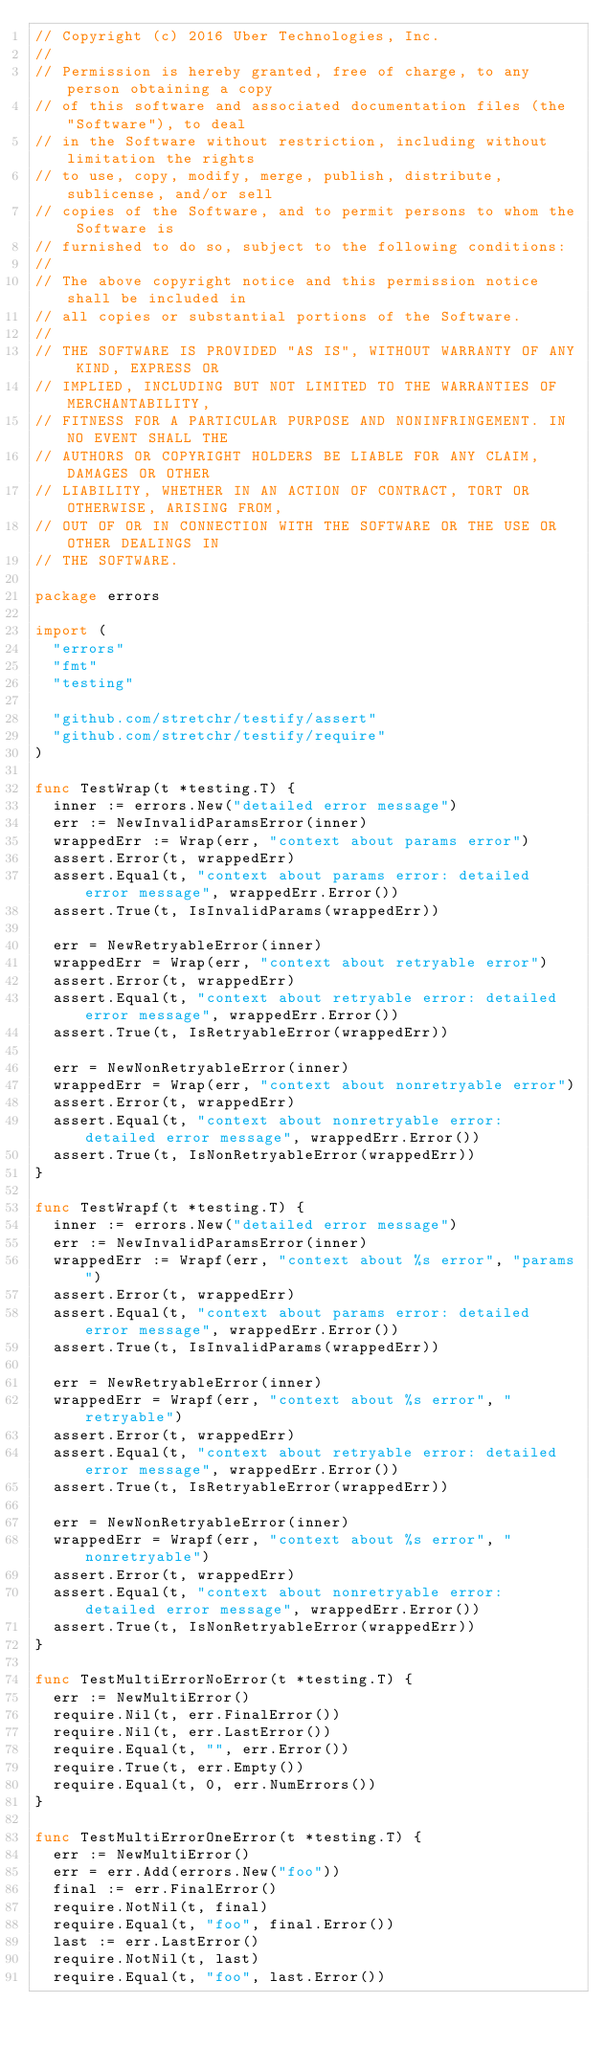<code> <loc_0><loc_0><loc_500><loc_500><_Go_>// Copyright (c) 2016 Uber Technologies, Inc.
//
// Permission is hereby granted, free of charge, to any person obtaining a copy
// of this software and associated documentation files (the "Software"), to deal
// in the Software without restriction, including without limitation the rights
// to use, copy, modify, merge, publish, distribute, sublicense, and/or sell
// copies of the Software, and to permit persons to whom the Software is
// furnished to do so, subject to the following conditions:
//
// The above copyright notice and this permission notice shall be included in
// all copies or substantial portions of the Software.
//
// THE SOFTWARE IS PROVIDED "AS IS", WITHOUT WARRANTY OF ANY KIND, EXPRESS OR
// IMPLIED, INCLUDING BUT NOT LIMITED TO THE WARRANTIES OF MERCHANTABILITY,
// FITNESS FOR A PARTICULAR PURPOSE AND NONINFRINGEMENT. IN NO EVENT SHALL THE
// AUTHORS OR COPYRIGHT HOLDERS BE LIABLE FOR ANY CLAIM, DAMAGES OR OTHER
// LIABILITY, WHETHER IN AN ACTION OF CONTRACT, TORT OR OTHERWISE, ARISING FROM,
// OUT OF OR IN CONNECTION WITH THE SOFTWARE OR THE USE OR OTHER DEALINGS IN
// THE SOFTWARE.

package errors

import (
	"errors"
	"fmt"
	"testing"

	"github.com/stretchr/testify/assert"
	"github.com/stretchr/testify/require"
)

func TestWrap(t *testing.T) {
	inner := errors.New("detailed error message")
	err := NewInvalidParamsError(inner)
	wrappedErr := Wrap(err, "context about params error")
	assert.Error(t, wrappedErr)
	assert.Equal(t, "context about params error: detailed error message", wrappedErr.Error())
	assert.True(t, IsInvalidParams(wrappedErr))

	err = NewRetryableError(inner)
	wrappedErr = Wrap(err, "context about retryable error")
	assert.Error(t, wrappedErr)
	assert.Equal(t, "context about retryable error: detailed error message", wrappedErr.Error())
	assert.True(t, IsRetryableError(wrappedErr))

	err = NewNonRetryableError(inner)
	wrappedErr = Wrap(err, "context about nonretryable error")
	assert.Error(t, wrappedErr)
	assert.Equal(t, "context about nonretryable error: detailed error message", wrappedErr.Error())
	assert.True(t, IsNonRetryableError(wrappedErr))
}

func TestWrapf(t *testing.T) {
	inner := errors.New("detailed error message")
	err := NewInvalidParamsError(inner)
	wrappedErr := Wrapf(err, "context about %s error", "params")
	assert.Error(t, wrappedErr)
	assert.Equal(t, "context about params error: detailed error message", wrappedErr.Error())
	assert.True(t, IsInvalidParams(wrappedErr))

	err = NewRetryableError(inner)
	wrappedErr = Wrapf(err, "context about %s error", "retryable")
	assert.Error(t, wrappedErr)
	assert.Equal(t, "context about retryable error: detailed error message", wrappedErr.Error())
	assert.True(t, IsRetryableError(wrappedErr))

	err = NewNonRetryableError(inner)
	wrappedErr = Wrapf(err, "context about %s error", "nonretryable")
	assert.Error(t, wrappedErr)
	assert.Equal(t, "context about nonretryable error: detailed error message", wrappedErr.Error())
	assert.True(t, IsNonRetryableError(wrappedErr))
}

func TestMultiErrorNoError(t *testing.T) {
	err := NewMultiError()
	require.Nil(t, err.FinalError())
	require.Nil(t, err.LastError())
	require.Equal(t, "", err.Error())
	require.True(t, err.Empty())
	require.Equal(t, 0, err.NumErrors())
}

func TestMultiErrorOneError(t *testing.T) {
	err := NewMultiError()
	err = err.Add(errors.New("foo"))
	final := err.FinalError()
	require.NotNil(t, final)
	require.Equal(t, "foo", final.Error())
	last := err.LastError()
	require.NotNil(t, last)
	require.Equal(t, "foo", last.Error())</code> 